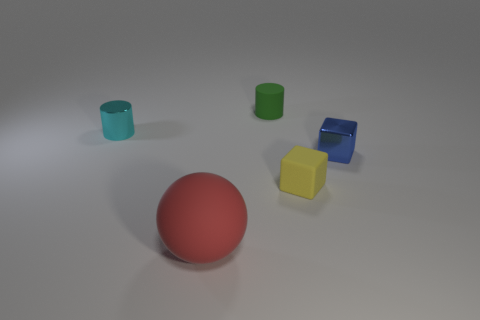Are there any other things that are the same size as the rubber ball?
Provide a succinct answer. No. There is another block that is the same size as the yellow rubber cube; what is its color?
Offer a very short reply. Blue. How many tiny objects are either green matte spheres or yellow matte blocks?
Your answer should be very brief. 1. Are there an equal number of small matte things that are behind the small metallic block and cyan shiny cylinders that are on the right side of the big red matte ball?
Make the answer very short. No. What number of red rubber things are the same size as the red matte sphere?
Your answer should be very brief. 0. How many yellow objects are either tiny shiny objects or shiny cubes?
Provide a short and direct response. 0. Is the number of big red spheres right of the big ball the same as the number of tiny matte cubes?
Offer a terse response. No. There is a metallic thing right of the small cyan shiny object; how big is it?
Ensure brevity in your answer.  Small. How many red objects are the same shape as the tiny blue object?
Provide a short and direct response. 0. What is the material of the object that is both to the right of the large red rubber object and to the left of the tiny yellow rubber object?
Keep it short and to the point. Rubber. 